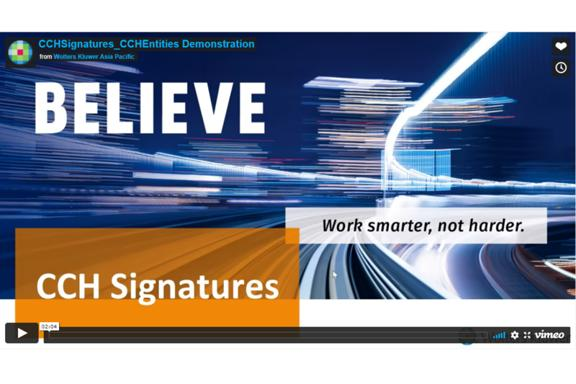How might the slogan 'Work smarter, not harder' apply to the services provided by Wolters Kluwer? This slogan aptly reflects Wolters Kluwer's commitment to developing solutions that enhance efficiency and effectiveness, allowing professionals in various fields to achieve better results with fewer resources and streamlined processes. Can you give an example of a tool or service from Wolters Kluwer that embodies this approach? One example is CCH Tagetik, a software solution designed to simplify complex financial processes for organizations, enhancing decision-making while reducing manual workload. 